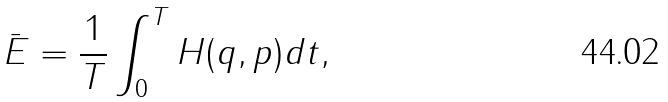<formula> <loc_0><loc_0><loc_500><loc_500>\bar { E } = \frac { 1 } { T } \int ^ { T } _ { 0 } H ( q , p ) d t ,</formula> 